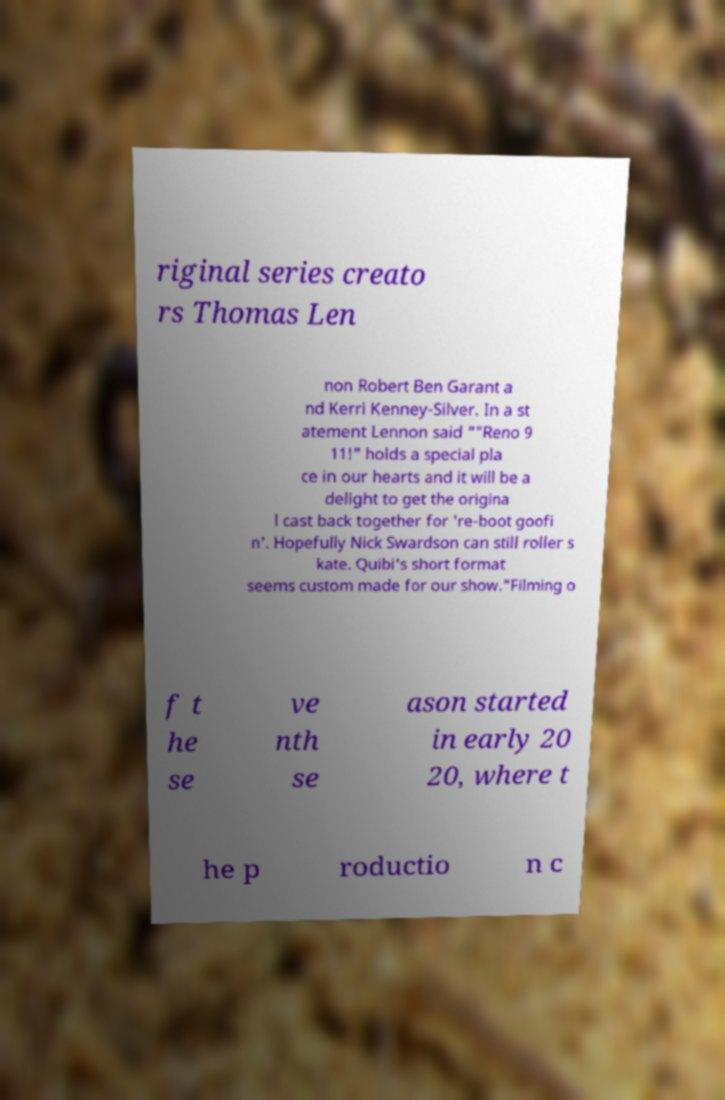Please identify and transcribe the text found in this image. riginal series creato rs Thomas Len non Robert Ben Garant a nd Kerri Kenney-Silver. In a st atement Lennon said ""Reno 9 11!" holds a special pla ce in our hearts and it will be a delight to get the origina l cast back together for 're-boot goofi n'. Hopefully Nick Swardson can still roller s kate. Quibi's short format seems custom made for our show."Filming o f t he se ve nth se ason started in early 20 20, where t he p roductio n c 